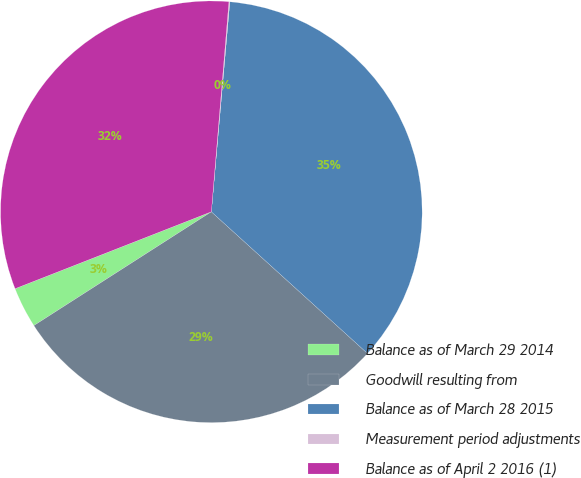<chart> <loc_0><loc_0><loc_500><loc_500><pie_chart><fcel>Balance as of March 29 2014<fcel>Goodwill resulting from<fcel>Balance as of March 28 2015<fcel>Measurement period adjustments<fcel>Balance as of April 2 2016 (1)<nl><fcel>3.13%<fcel>29.2%<fcel>35.33%<fcel>0.07%<fcel>32.27%<nl></chart> 